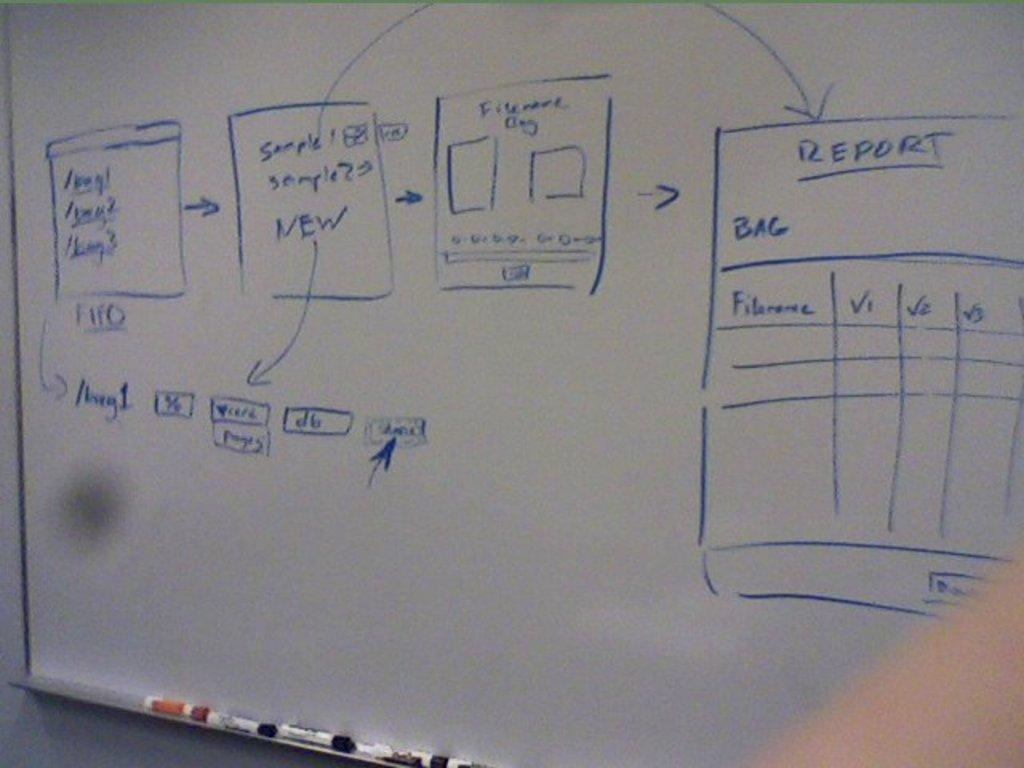<image>
Provide a brief description of the given image. Various things are drawn on a white board and lead to a drawing titled Report. 